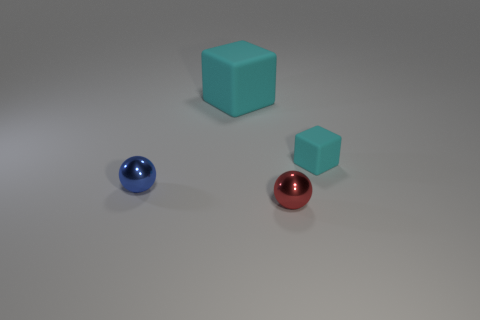Is there a red sphere of the same size as the blue metal sphere?
Provide a short and direct response. Yes. What shape is the other matte thing that is the same size as the red thing?
Keep it short and to the point. Cube. How many other objects are there of the same color as the small cube?
Your answer should be very brief. 1. The object that is on the left side of the small red sphere and behind the blue thing has what shape?
Make the answer very short. Cube. Are there any tiny metallic balls on the left side of the small ball that is on the left side of the tiny red object in front of the tiny blue thing?
Your response must be concise. No. What number of other objects are there of the same material as the tiny cyan object?
Keep it short and to the point. 1. How many tiny shiny balls are there?
Offer a very short reply. 2. How many things are either large brown matte cylinders or objects that are in front of the large matte thing?
Your answer should be compact. 3. Is there any other thing that is the same shape as the large matte object?
Your response must be concise. Yes. There is a ball on the right side of the blue shiny object; is its size the same as the small cyan object?
Offer a terse response. Yes. 